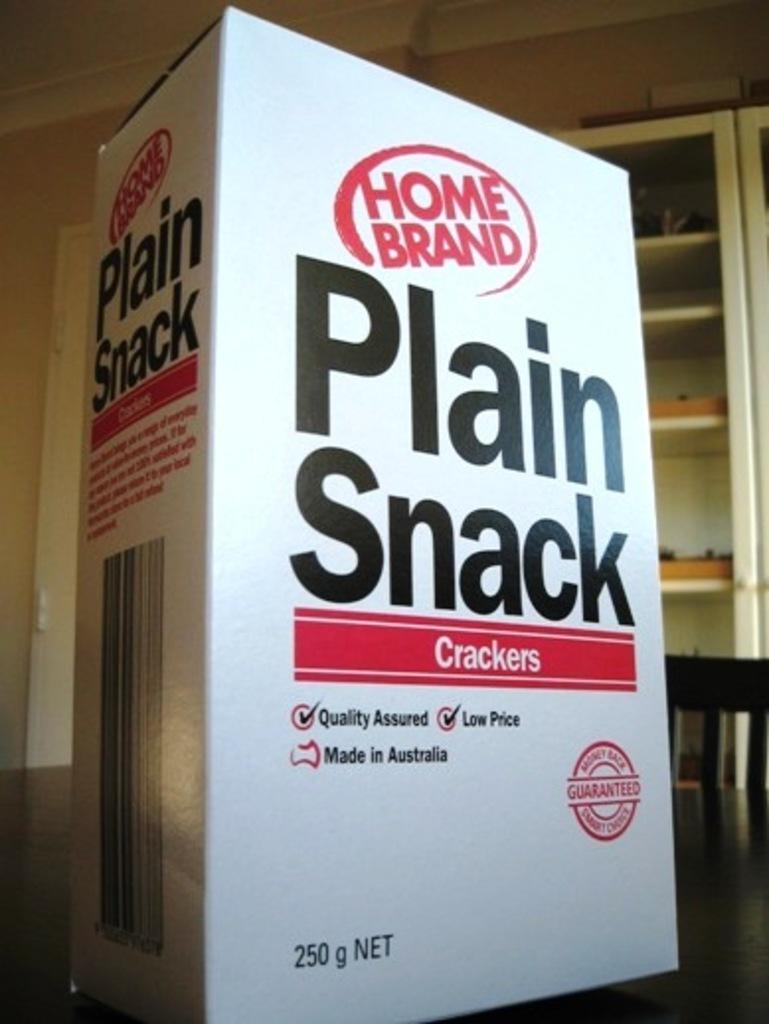Describe this image in one or two sentences. In this image in the front there is a board with some text and numbers written on it, which is on the table. In the center there is an empty chair and in the background there is a shelf and in the shelf there are objects which are brown and black in colour and on the top of the shelf there is a white colour object. On the left side there is a door which is white in colour. 